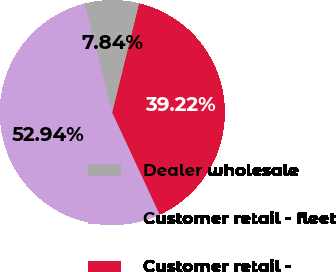<chart> <loc_0><loc_0><loc_500><loc_500><pie_chart><fcel>Dealer wholesale<fcel>Customer retail - fleet<fcel>Customer retail -<nl><fcel>7.84%<fcel>52.94%<fcel>39.22%<nl></chart> 